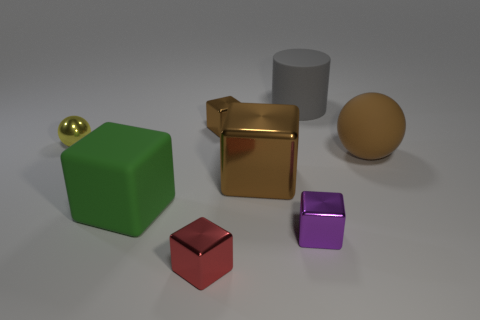How many objects are there in the image? There are six objects visible in the image, including a variety of geometric shapes. What shapes can you identify? The shapes include a cube, a sphere, a cylinder, and rectangular solids of different sizes. 